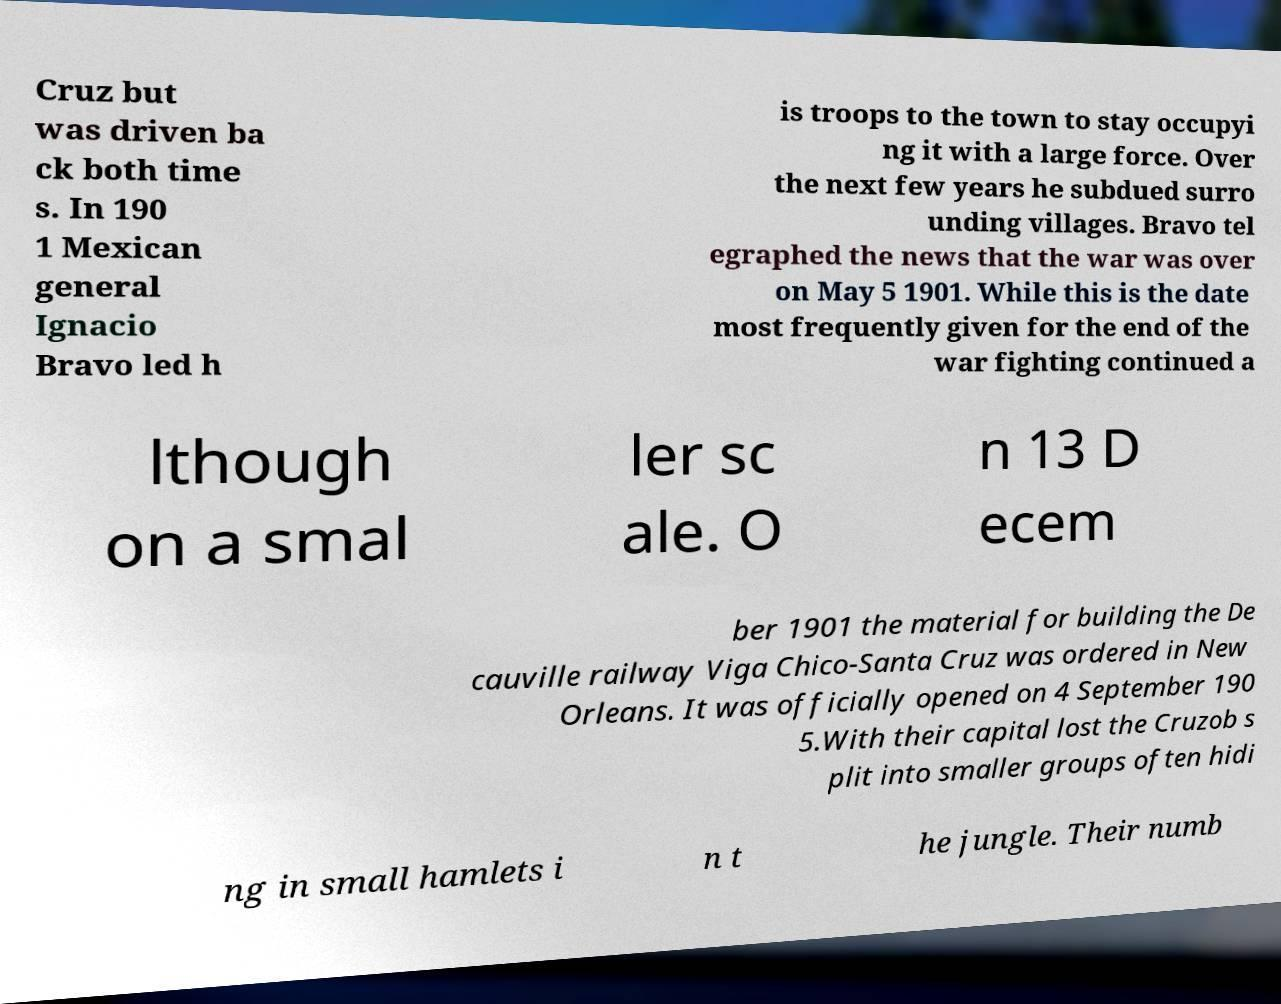There's text embedded in this image that I need extracted. Can you transcribe it verbatim? Cruz but was driven ba ck both time s. In 190 1 Mexican general Ignacio Bravo led h is troops to the town to stay occupyi ng it with a large force. Over the next few years he subdued surro unding villages. Bravo tel egraphed the news that the war was over on May 5 1901. While this is the date most frequently given for the end of the war fighting continued a lthough on a smal ler sc ale. O n 13 D ecem ber 1901 the material for building the De cauville railway Viga Chico-Santa Cruz was ordered in New Orleans. It was officially opened on 4 September 190 5.With their capital lost the Cruzob s plit into smaller groups often hidi ng in small hamlets i n t he jungle. Their numb 